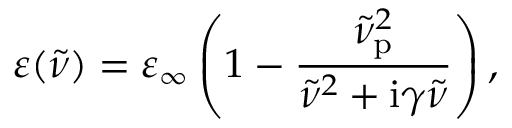<formula> <loc_0><loc_0><loc_500><loc_500>\varepsilon ( \tilde { \nu } ) = \varepsilon _ { \infty } \left ( 1 - \frac { \tilde { \nu } _ { p } ^ { 2 } } { \tilde { \nu } ^ { 2 } + i \gamma \tilde { \nu } } \right ) ,</formula> 